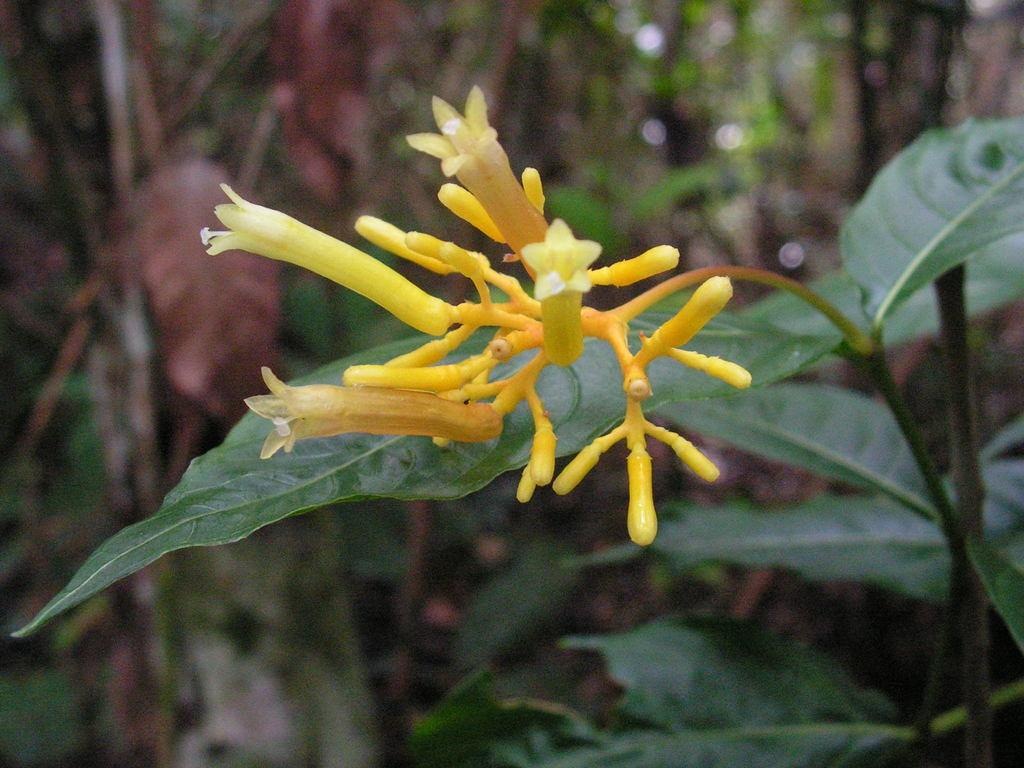What type of flowers can be seen in the image? There are yellow color flowers in the image. What color are the leaves in the image? There are green color leaves in the image. How would you describe the overall clarity of the image? The image is slightly blurry in the background. What type of bell can be heard ringing in the image? There is no bell present in the image, and therefore no sound can be heard. 